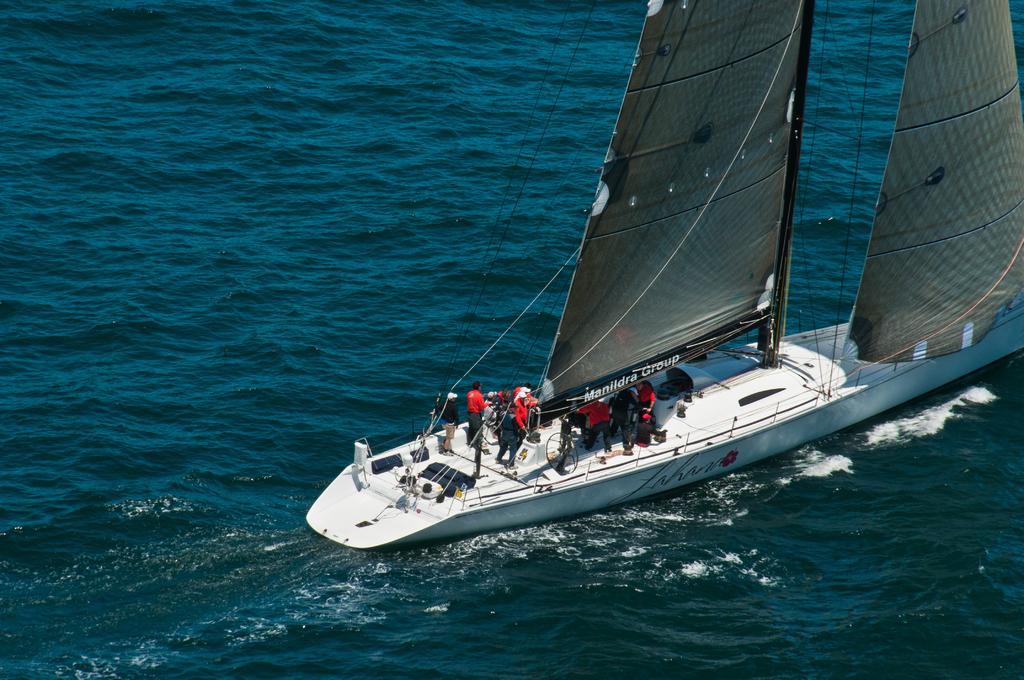Can you describe this image briefly? In this image I can see the boat on the water. The boat is in white color and I can see the group of people standing on the boat. These people are wearing the red and black color dresses and I can see one person with the cap. I can see the water in blue color. 